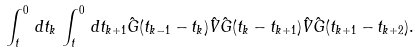Convert formula to latex. <formula><loc_0><loc_0><loc_500><loc_500>\int _ { t } ^ { 0 } \, d t _ { k } \, \int _ { t } ^ { 0 } \, d t _ { k + 1 } \hat { G } ( t _ { k - 1 } - t _ { k } ) \hat { V } \hat { G } ( t _ { k } - t _ { k + 1 } ) \hat { V } \hat { G } ( t _ { k + 1 } - t _ { k + 2 } ) .</formula> 